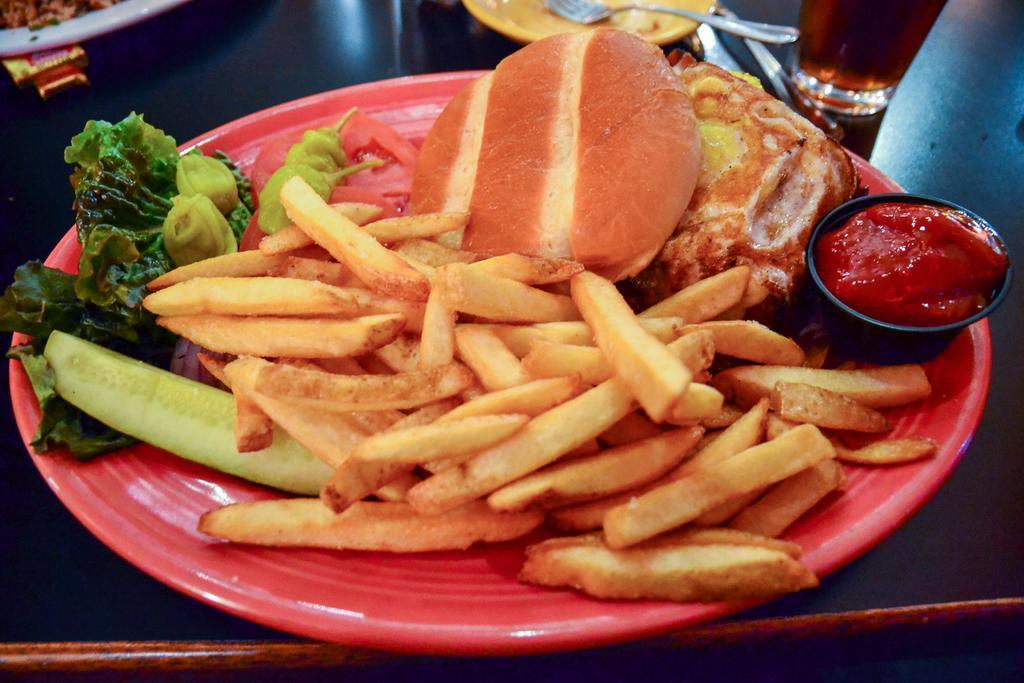Can you describe this image briefly? In this image we can see food in the plate, bowl, fork, plate, and a glass with liquid on a table. 